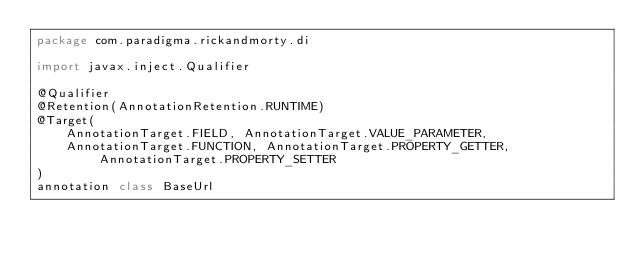<code> <loc_0><loc_0><loc_500><loc_500><_Kotlin_>package com.paradigma.rickandmorty.di

import javax.inject.Qualifier

@Qualifier
@Retention(AnnotationRetention.RUNTIME)
@Target(
    AnnotationTarget.FIELD, AnnotationTarget.VALUE_PARAMETER,
    AnnotationTarget.FUNCTION, AnnotationTarget.PROPERTY_GETTER, AnnotationTarget.PROPERTY_SETTER
)
annotation class BaseUrl
</code> 